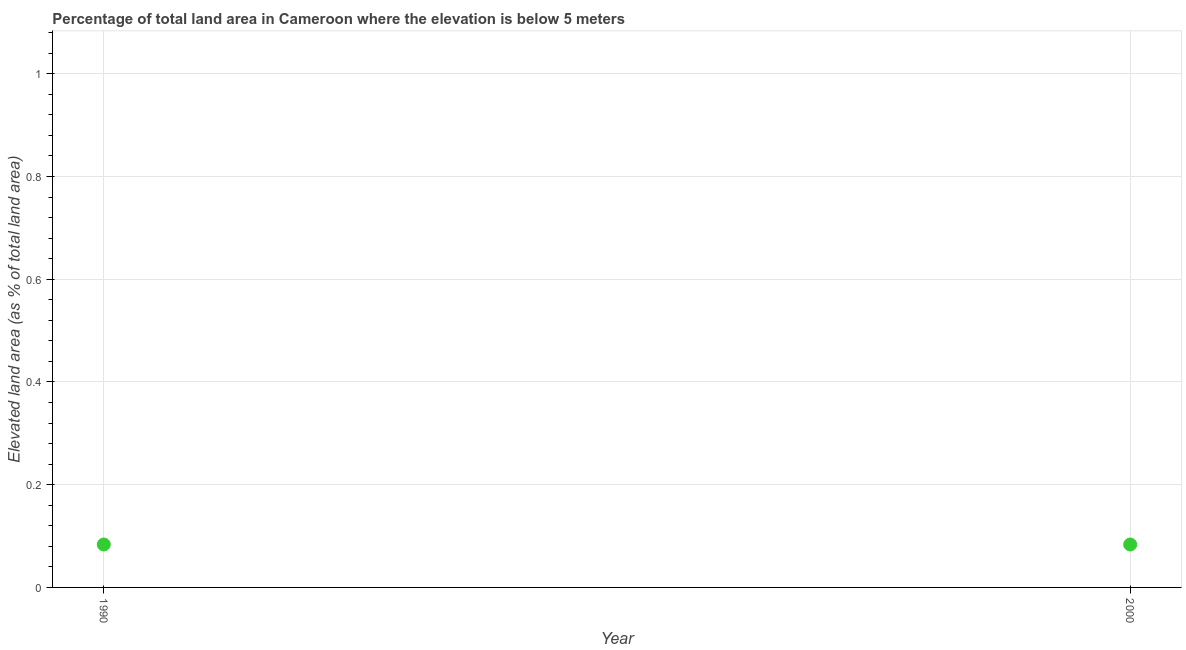What is the total elevated land area in 1990?
Offer a terse response. 0.08. Across all years, what is the maximum total elevated land area?
Provide a succinct answer. 0.08. Across all years, what is the minimum total elevated land area?
Provide a succinct answer. 0.08. In which year was the total elevated land area maximum?
Provide a succinct answer. 1990. In which year was the total elevated land area minimum?
Your answer should be very brief. 1990. What is the sum of the total elevated land area?
Make the answer very short. 0.17. What is the average total elevated land area per year?
Your answer should be compact. 0.08. What is the median total elevated land area?
Offer a very short reply. 0.08. In how many years, is the total elevated land area greater than 0.7600000000000001 %?
Your response must be concise. 0. Is the total elevated land area in 1990 less than that in 2000?
Your answer should be very brief. No. In how many years, is the total elevated land area greater than the average total elevated land area taken over all years?
Make the answer very short. 0. How many dotlines are there?
Make the answer very short. 1. How many years are there in the graph?
Your response must be concise. 2. Are the values on the major ticks of Y-axis written in scientific E-notation?
Your answer should be very brief. No. Does the graph contain any zero values?
Offer a very short reply. No. What is the title of the graph?
Provide a short and direct response. Percentage of total land area in Cameroon where the elevation is below 5 meters. What is the label or title of the Y-axis?
Provide a succinct answer. Elevated land area (as % of total land area). What is the Elevated land area (as % of total land area) in 1990?
Your answer should be compact. 0.08. What is the Elevated land area (as % of total land area) in 2000?
Your answer should be compact. 0.08. 